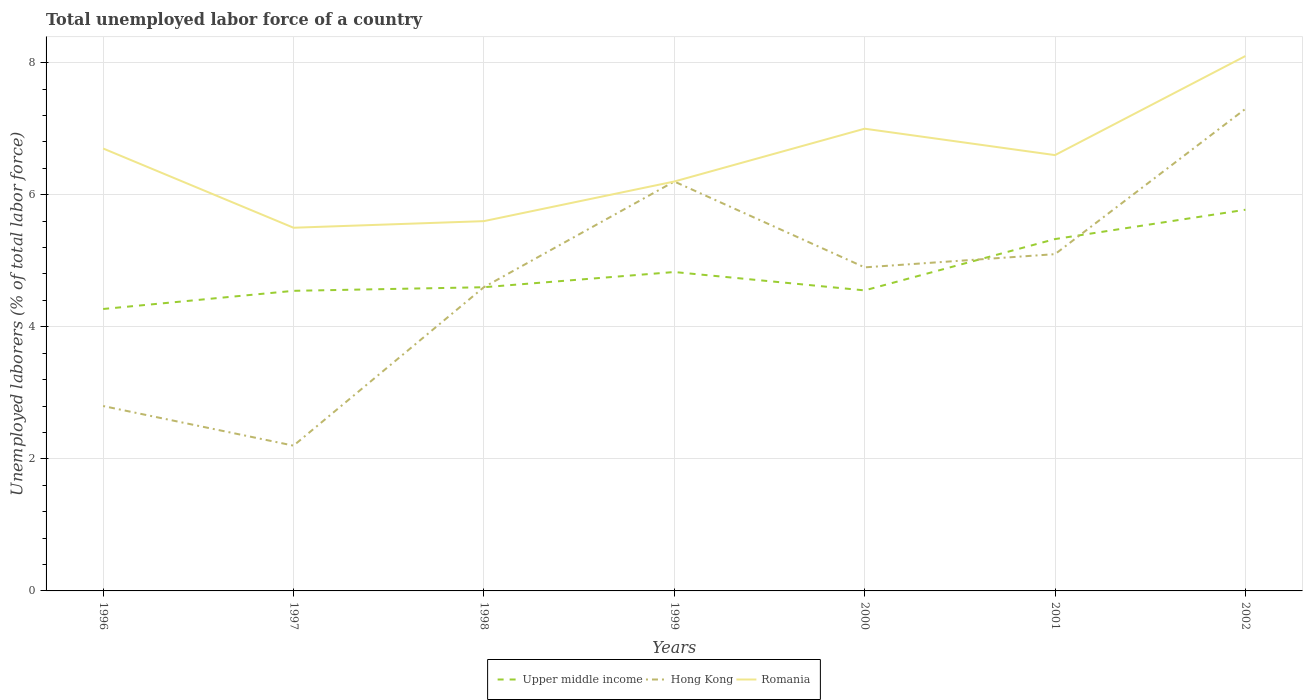How many different coloured lines are there?
Your answer should be very brief. 3. Does the line corresponding to Romania intersect with the line corresponding to Upper middle income?
Offer a very short reply. No. Across all years, what is the maximum total unemployed labor force in Hong Kong?
Provide a succinct answer. 2.2. What is the total total unemployed labor force in Hong Kong in the graph?
Make the answer very short. -1.8. What is the difference between the highest and the second highest total unemployed labor force in Upper middle income?
Keep it short and to the point. 1.5. What is the difference between the highest and the lowest total unemployed labor force in Hong Kong?
Offer a terse response. 4. Is the total unemployed labor force in Upper middle income strictly greater than the total unemployed labor force in Hong Kong over the years?
Make the answer very short. No. How many lines are there?
Offer a very short reply. 3. How many years are there in the graph?
Provide a short and direct response. 7. Are the values on the major ticks of Y-axis written in scientific E-notation?
Provide a short and direct response. No. Does the graph contain any zero values?
Your response must be concise. No. Where does the legend appear in the graph?
Ensure brevity in your answer.  Bottom center. How many legend labels are there?
Your answer should be compact. 3. What is the title of the graph?
Your answer should be very brief. Total unemployed labor force of a country. What is the label or title of the X-axis?
Offer a terse response. Years. What is the label or title of the Y-axis?
Your response must be concise. Unemployed laborers (% of total labor force). What is the Unemployed laborers (% of total labor force) in Upper middle income in 1996?
Your response must be concise. 4.27. What is the Unemployed laborers (% of total labor force) of Hong Kong in 1996?
Offer a terse response. 2.8. What is the Unemployed laborers (% of total labor force) of Romania in 1996?
Offer a very short reply. 6.7. What is the Unemployed laborers (% of total labor force) in Upper middle income in 1997?
Ensure brevity in your answer.  4.54. What is the Unemployed laborers (% of total labor force) of Hong Kong in 1997?
Give a very brief answer. 2.2. What is the Unemployed laborers (% of total labor force) in Romania in 1997?
Make the answer very short. 5.5. What is the Unemployed laborers (% of total labor force) of Upper middle income in 1998?
Ensure brevity in your answer.  4.6. What is the Unemployed laborers (% of total labor force) of Hong Kong in 1998?
Your answer should be very brief. 4.6. What is the Unemployed laborers (% of total labor force) in Romania in 1998?
Offer a terse response. 5.6. What is the Unemployed laborers (% of total labor force) of Upper middle income in 1999?
Your response must be concise. 4.83. What is the Unemployed laborers (% of total labor force) of Hong Kong in 1999?
Offer a terse response. 6.2. What is the Unemployed laborers (% of total labor force) in Romania in 1999?
Your response must be concise. 6.2. What is the Unemployed laborers (% of total labor force) in Upper middle income in 2000?
Your answer should be very brief. 4.55. What is the Unemployed laborers (% of total labor force) in Hong Kong in 2000?
Give a very brief answer. 4.9. What is the Unemployed laborers (% of total labor force) of Upper middle income in 2001?
Your answer should be very brief. 5.33. What is the Unemployed laborers (% of total labor force) in Hong Kong in 2001?
Provide a short and direct response. 5.1. What is the Unemployed laborers (% of total labor force) in Romania in 2001?
Provide a short and direct response. 6.6. What is the Unemployed laborers (% of total labor force) of Upper middle income in 2002?
Ensure brevity in your answer.  5.77. What is the Unemployed laborers (% of total labor force) of Hong Kong in 2002?
Your answer should be compact. 7.3. What is the Unemployed laborers (% of total labor force) of Romania in 2002?
Your answer should be very brief. 8.1. Across all years, what is the maximum Unemployed laborers (% of total labor force) of Upper middle income?
Make the answer very short. 5.77. Across all years, what is the maximum Unemployed laborers (% of total labor force) in Hong Kong?
Your response must be concise. 7.3. Across all years, what is the maximum Unemployed laborers (% of total labor force) of Romania?
Your answer should be very brief. 8.1. Across all years, what is the minimum Unemployed laborers (% of total labor force) in Upper middle income?
Make the answer very short. 4.27. Across all years, what is the minimum Unemployed laborers (% of total labor force) of Hong Kong?
Offer a very short reply. 2.2. Across all years, what is the minimum Unemployed laborers (% of total labor force) in Romania?
Make the answer very short. 5.5. What is the total Unemployed laborers (% of total labor force) in Upper middle income in the graph?
Provide a short and direct response. 33.9. What is the total Unemployed laborers (% of total labor force) in Hong Kong in the graph?
Your response must be concise. 33.1. What is the total Unemployed laborers (% of total labor force) in Romania in the graph?
Your response must be concise. 45.7. What is the difference between the Unemployed laborers (% of total labor force) in Upper middle income in 1996 and that in 1997?
Give a very brief answer. -0.28. What is the difference between the Unemployed laborers (% of total labor force) of Hong Kong in 1996 and that in 1997?
Keep it short and to the point. 0.6. What is the difference between the Unemployed laborers (% of total labor force) of Romania in 1996 and that in 1997?
Make the answer very short. 1.2. What is the difference between the Unemployed laborers (% of total labor force) in Upper middle income in 1996 and that in 1998?
Offer a terse response. -0.33. What is the difference between the Unemployed laborers (% of total labor force) in Upper middle income in 1996 and that in 1999?
Keep it short and to the point. -0.56. What is the difference between the Unemployed laborers (% of total labor force) of Romania in 1996 and that in 1999?
Make the answer very short. 0.5. What is the difference between the Unemployed laborers (% of total labor force) in Upper middle income in 1996 and that in 2000?
Your answer should be compact. -0.28. What is the difference between the Unemployed laborers (% of total labor force) in Romania in 1996 and that in 2000?
Your response must be concise. -0.3. What is the difference between the Unemployed laborers (% of total labor force) in Upper middle income in 1996 and that in 2001?
Make the answer very short. -1.06. What is the difference between the Unemployed laborers (% of total labor force) in Upper middle income in 1996 and that in 2002?
Ensure brevity in your answer.  -1.5. What is the difference between the Unemployed laborers (% of total labor force) in Hong Kong in 1996 and that in 2002?
Ensure brevity in your answer.  -4.5. What is the difference between the Unemployed laborers (% of total labor force) of Upper middle income in 1997 and that in 1998?
Offer a terse response. -0.05. What is the difference between the Unemployed laborers (% of total labor force) in Hong Kong in 1997 and that in 1998?
Ensure brevity in your answer.  -2.4. What is the difference between the Unemployed laborers (% of total labor force) in Upper middle income in 1997 and that in 1999?
Your response must be concise. -0.28. What is the difference between the Unemployed laborers (% of total labor force) of Romania in 1997 and that in 1999?
Ensure brevity in your answer.  -0.7. What is the difference between the Unemployed laborers (% of total labor force) in Upper middle income in 1997 and that in 2000?
Provide a succinct answer. -0.01. What is the difference between the Unemployed laborers (% of total labor force) in Hong Kong in 1997 and that in 2000?
Your answer should be compact. -2.7. What is the difference between the Unemployed laborers (% of total labor force) of Romania in 1997 and that in 2000?
Your answer should be compact. -1.5. What is the difference between the Unemployed laborers (% of total labor force) of Upper middle income in 1997 and that in 2001?
Offer a terse response. -0.78. What is the difference between the Unemployed laborers (% of total labor force) of Hong Kong in 1997 and that in 2001?
Offer a very short reply. -2.9. What is the difference between the Unemployed laborers (% of total labor force) in Romania in 1997 and that in 2001?
Give a very brief answer. -1.1. What is the difference between the Unemployed laborers (% of total labor force) of Upper middle income in 1997 and that in 2002?
Your answer should be very brief. -1.23. What is the difference between the Unemployed laborers (% of total labor force) in Hong Kong in 1997 and that in 2002?
Your answer should be compact. -5.1. What is the difference between the Unemployed laborers (% of total labor force) of Upper middle income in 1998 and that in 1999?
Give a very brief answer. -0.23. What is the difference between the Unemployed laborers (% of total labor force) in Upper middle income in 1998 and that in 2000?
Your response must be concise. 0.05. What is the difference between the Unemployed laborers (% of total labor force) in Hong Kong in 1998 and that in 2000?
Offer a very short reply. -0.3. What is the difference between the Unemployed laborers (% of total labor force) in Romania in 1998 and that in 2000?
Offer a terse response. -1.4. What is the difference between the Unemployed laborers (% of total labor force) of Upper middle income in 1998 and that in 2001?
Offer a terse response. -0.73. What is the difference between the Unemployed laborers (% of total labor force) in Upper middle income in 1998 and that in 2002?
Ensure brevity in your answer.  -1.17. What is the difference between the Unemployed laborers (% of total labor force) in Romania in 1998 and that in 2002?
Offer a terse response. -2.5. What is the difference between the Unemployed laborers (% of total labor force) in Upper middle income in 1999 and that in 2000?
Provide a short and direct response. 0.28. What is the difference between the Unemployed laborers (% of total labor force) in Hong Kong in 1999 and that in 2000?
Provide a short and direct response. 1.3. What is the difference between the Unemployed laborers (% of total labor force) of Upper middle income in 1999 and that in 2001?
Your answer should be very brief. -0.5. What is the difference between the Unemployed laborers (% of total labor force) in Hong Kong in 1999 and that in 2001?
Make the answer very short. 1.1. What is the difference between the Unemployed laborers (% of total labor force) of Romania in 1999 and that in 2001?
Offer a very short reply. -0.4. What is the difference between the Unemployed laborers (% of total labor force) of Upper middle income in 1999 and that in 2002?
Ensure brevity in your answer.  -0.94. What is the difference between the Unemployed laborers (% of total labor force) of Upper middle income in 2000 and that in 2001?
Offer a very short reply. -0.78. What is the difference between the Unemployed laborers (% of total labor force) in Upper middle income in 2000 and that in 2002?
Make the answer very short. -1.22. What is the difference between the Unemployed laborers (% of total labor force) in Romania in 2000 and that in 2002?
Your answer should be compact. -1.1. What is the difference between the Unemployed laborers (% of total labor force) of Upper middle income in 2001 and that in 2002?
Your answer should be compact. -0.44. What is the difference between the Unemployed laborers (% of total labor force) of Hong Kong in 2001 and that in 2002?
Offer a terse response. -2.2. What is the difference between the Unemployed laborers (% of total labor force) in Upper middle income in 1996 and the Unemployed laborers (% of total labor force) in Hong Kong in 1997?
Keep it short and to the point. 2.07. What is the difference between the Unemployed laborers (% of total labor force) in Upper middle income in 1996 and the Unemployed laborers (% of total labor force) in Romania in 1997?
Ensure brevity in your answer.  -1.23. What is the difference between the Unemployed laborers (% of total labor force) of Hong Kong in 1996 and the Unemployed laborers (% of total labor force) of Romania in 1997?
Provide a succinct answer. -2.7. What is the difference between the Unemployed laborers (% of total labor force) of Upper middle income in 1996 and the Unemployed laborers (% of total labor force) of Hong Kong in 1998?
Your response must be concise. -0.33. What is the difference between the Unemployed laborers (% of total labor force) of Upper middle income in 1996 and the Unemployed laborers (% of total labor force) of Romania in 1998?
Make the answer very short. -1.33. What is the difference between the Unemployed laborers (% of total labor force) in Upper middle income in 1996 and the Unemployed laborers (% of total labor force) in Hong Kong in 1999?
Provide a short and direct response. -1.93. What is the difference between the Unemployed laborers (% of total labor force) of Upper middle income in 1996 and the Unemployed laborers (% of total labor force) of Romania in 1999?
Provide a succinct answer. -1.93. What is the difference between the Unemployed laborers (% of total labor force) of Upper middle income in 1996 and the Unemployed laborers (% of total labor force) of Hong Kong in 2000?
Your answer should be very brief. -0.63. What is the difference between the Unemployed laborers (% of total labor force) of Upper middle income in 1996 and the Unemployed laborers (% of total labor force) of Romania in 2000?
Offer a terse response. -2.73. What is the difference between the Unemployed laborers (% of total labor force) in Upper middle income in 1996 and the Unemployed laborers (% of total labor force) in Hong Kong in 2001?
Your answer should be very brief. -0.83. What is the difference between the Unemployed laborers (% of total labor force) in Upper middle income in 1996 and the Unemployed laborers (% of total labor force) in Romania in 2001?
Ensure brevity in your answer.  -2.33. What is the difference between the Unemployed laborers (% of total labor force) of Hong Kong in 1996 and the Unemployed laborers (% of total labor force) of Romania in 2001?
Your answer should be compact. -3.8. What is the difference between the Unemployed laborers (% of total labor force) in Upper middle income in 1996 and the Unemployed laborers (% of total labor force) in Hong Kong in 2002?
Your answer should be very brief. -3.03. What is the difference between the Unemployed laborers (% of total labor force) in Upper middle income in 1996 and the Unemployed laborers (% of total labor force) in Romania in 2002?
Your response must be concise. -3.83. What is the difference between the Unemployed laborers (% of total labor force) in Hong Kong in 1996 and the Unemployed laborers (% of total labor force) in Romania in 2002?
Your answer should be compact. -5.3. What is the difference between the Unemployed laborers (% of total labor force) of Upper middle income in 1997 and the Unemployed laborers (% of total labor force) of Hong Kong in 1998?
Ensure brevity in your answer.  -0.06. What is the difference between the Unemployed laborers (% of total labor force) of Upper middle income in 1997 and the Unemployed laborers (% of total labor force) of Romania in 1998?
Keep it short and to the point. -1.06. What is the difference between the Unemployed laborers (% of total labor force) of Hong Kong in 1997 and the Unemployed laborers (% of total labor force) of Romania in 1998?
Give a very brief answer. -3.4. What is the difference between the Unemployed laborers (% of total labor force) of Upper middle income in 1997 and the Unemployed laborers (% of total labor force) of Hong Kong in 1999?
Your response must be concise. -1.66. What is the difference between the Unemployed laborers (% of total labor force) of Upper middle income in 1997 and the Unemployed laborers (% of total labor force) of Romania in 1999?
Keep it short and to the point. -1.66. What is the difference between the Unemployed laborers (% of total labor force) in Upper middle income in 1997 and the Unemployed laborers (% of total labor force) in Hong Kong in 2000?
Offer a terse response. -0.36. What is the difference between the Unemployed laborers (% of total labor force) in Upper middle income in 1997 and the Unemployed laborers (% of total labor force) in Romania in 2000?
Offer a very short reply. -2.46. What is the difference between the Unemployed laborers (% of total labor force) of Hong Kong in 1997 and the Unemployed laborers (% of total labor force) of Romania in 2000?
Give a very brief answer. -4.8. What is the difference between the Unemployed laborers (% of total labor force) of Upper middle income in 1997 and the Unemployed laborers (% of total labor force) of Hong Kong in 2001?
Ensure brevity in your answer.  -0.56. What is the difference between the Unemployed laborers (% of total labor force) of Upper middle income in 1997 and the Unemployed laborers (% of total labor force) of Romania in 2001?
Your answer should be very brief. -2.06. What is the difference between the Unemployed laborers (% of total labor force) of Hong Kong in 1997 and the Unemployed laborers (% of total labor force) of Romania in 2001?
Ensure brevity in your answer.  -4.4. What is the difference between the Unemployed laborers (% of total labor force) in Upper middle income in 1997 and the Unemployed laborers (% of total labor force) in Hong Kong in 2002?
Keep it short and to the point. -2.76. What is the difference between the Unemployed laborers (% of total labor force) of Upper middle income in 1997 and the Unemployed laborers (% of total labor force) of Romania in 2002?
Your response must be concise. -3.56. What is the difference between the Unemployed laborers (% of total labor force) of Hong Kong in 1997 and the Unemployed laborers (% of total labor force) of Romania in 2002?
Make the answer very short. -5.9. What is the difference between the Unemployed laborers (% of total labor force) in Upper middle income in 1998 and the Unemployed laborers (% of total labor force) in Hong Kong in 1999?
Offer a terse response. -1.6. What is the difference between the Unemployed laborers (% of total labor force) in Upper middle income in 1998 and the Unemployed laborers (% of total labor force) in Romania in 1999?
Ensure brevity in your answer.  -1.6. What is the difference between the Unemployed laborers (% of total labor force) in Upper middle income in 1998 and the Unemployed laborers (% of total labor force) in Hong Kong in 2000?
Your response must be concise. -0.3. What is the difference between the Unemployed laborers (% of total labor force) in Upper middle income in 1998 and the Unemployed laborers (% of total labor force) in Romania in 2000?
Provide a succinct answer. -2.4. What is the difference between the Unemployed laborers (% of total labor force) of Upper middle income in 1998 and the Unemployed laborers (% of total labor force) of Hong Kong in 2001?
Keep it short and to the point. -0.5. What is the difference between the Unemployed laborers (% of total labor force) of Upper middle income in 1998 and the Unemployed laborers (% of total labor force) of Romania in 2001?
Provide a short and direct response. -2. What is the difference between the Unemployed laborers (% of total labor force) of Hong Kong in 1998 and the Unemployed laborers (% of total labor force) of Romania in 2001?
Offer a very short reply. -2. What is the difference between the Unemployed laborers (% of total labor force) of Upper middle income in 1998 and the Unemployed laborers (% of total labor force) of Hong Kong in 2002?
Your answer should be very brief. -2.7. What is the difference between the Unemployed laborers (% of total labor force) in Upper middle income in 1998 and the Unemployed laborers (% of total labor force) in Romania in 2002?
Provide a succinct answer. -3.5. What is the difference between the Unemployed laborers (% of total labor force) in Hong Kong in 1998 and the Unemployed laborers (% of total labor force) in Romania in 2002?
Keep it short and to the point. -3.5. What is the difference between the Unemployed laborers (% of total labor force) in Upper middle income in 1999 and the Unemployed laborers (% of total labor force) in Hong Kong in 2000?
Keep it short and to the point. -0.07. What is the difference between the Unemployed laborers (% of total labor force) in Upper middle income in 1999 and the Unemployed laborers (% of total labor force) in Romania in 2000?
Give a very brief answer. -2.17. What is the difference between the Unemployed laborers (% of total labor force) in Hong Kong in 1999 and the Unemployed laborers (% of total labor force) in Romania in 2000?
Your answer should be compact. -0.8. What is the difference between the Unemployed laborers (% of total labor force) of Upper middle income in 1999 and the Unemployed laborers (% of total labor force) of Hong Kong in 2001?
Make the answer very short. -0.27. What is the difference between the Unemployed laborers (% of total labor force) in Upper middle income in 1999 and the Unemployed laborers (% of total labor force) in Romania in 2001?
Provide a short and direct response. -1.77. What is the difference between the Unemployed laborers (% of total labor force) in Hong Kong in 1999 and the Unemployed laborers (% of total labor force) in Romania in 2001?
Provide a short and direct response. -0.4. What is the difference between the Unemployed laborers (% of total labor force) of Upper middle income in 1999 and the Unemployed laborers (% of total labor force) of Hong Kong in 2002?
Give a very brief answer. -2.47. What is the difference between the Unemployed laborers (% of total labor force) of Upper middle income in 1999 and the Unemployed laborers (% of total labor force) of Romania in 2002?
Provide a short and direct response. -3.27. What is the difference between the Unemployed laborers (% of total labor force) in Hong Kong in 1999 and the Unemployed laborers (% of total labor force) in Romania in 2002?
Offer a terse response. -1.9. What is the difference between the Unemployed laborers (% of total labor force) in Upper middle income in 2000 and the Unemployed laborers (% of total labor force) in Hong Kong in 2001?
Ensure brevity in your answer.  -0.55. What is the difference between the Unemployed laborers (% of total labor force) of Upper middle income in 2000 and the Unemployed laborers (% of total labor force) of Romania in 2001?
Offer a terse response. -2.05. What is the difference between the Unemployed laborers (% of total labor force) in Hong Kong in 2000 and the Unemployed laborers (% of total labor force) in Romania in 2001?
Your answer should be very brief. -1.7. What is the difference between the Unemployed laborers (% of total labor force) in Upper middle income in 2000 and the Unemployed laborers (% of total labor force) in Hong Kong in 2002?
Keep it short and to the point. -2.75. What is the difference between the Unemployed laborers (% of total labor force) of Upper middle income in 2000 and the Unemployed laborers (% of total labor force) of Romania in 2002?
Ensure brevity in your answer.  -3.55. What is the difference between the Unemployed laborers (% of total labor force) in Upper middle income in 2001 and the Unemployed laborers (% of total labor force) in Hong Kong in 2002?
Provide a short and direct response. -1.97. What is the difference between the Unemployed laborers (% of total labor force) of Upper middle income in 2001 and the Unemployed laborers (% of total labor force) of Romania in 2002?
Provide a succinct answer. -2.77. What is the average Unemployed laborers (% of total labor force) of Upper middle income per year?
Offer a very short reply. 4.84. What is the average Unemployed laborers (% of total labor force) of Hong Kong per year?
Your answer should be very brief. 4.73. What is the average Unemployed laborers (% of total labor force) of Romania per year?
Ensure brevity in your answer.  6.53. In the year 1996, what is the difference between the Unemployed laborers (% of total labor force) in Upper middle income and Unemployed laborers (% of total labor force) in Hong Kong?
Give a very brief answer. 1.47. In the year 1996, what is the difference between the Unemployed laborers (% of total labor force) of Upper middle income and Unemployed laborers (% of total labor force) of Romania?
Your answer should be compact. -2.43. In the year 1996, what is the difference between the Unemployed laborers (% of total labor force) of Hong Kong and Unemployed laborers (% of total labor force) of Romania?
Your answer should be very brief. -3.9. In the year 1997, what is the difference between the Unemployed laborers (% of total labor force) of Upper middle income and Unemployed laborers (% of total labor force) of Hong Kong?
Provide a short and direct response. 2.34. In the year 1997, what is the difference between the Unemployed laborers (% of total labor force) of Upper middle income and Unemployed laborers (% of total labor force) of Romania?
Keep it short and to the point. -0.96. In the year 1997, what is the difference between the Unemployed laborers (% of total labor force) of Hong Kong and Unemployed laborers (% of total labor force) of Romania?
Provide a succinct answer. -3.3. In the year 1998, what is the difference between the Unemployed laborers (% of total labor force) in Upper middle income and Unemployed laborers (% of total labor force) in Hong Kong?
Offer a very short reply. -0. In the year 1998, what is the difference between the Unemployed laborers (% of total labor force) of Upper middle income and Unemployed laborers (% of total labor force) of Romania?
Offer a very short reply. -1. In the year 1999, what is the difference between the Unemployed laborers (% of total labor force) of Upper middle income and Unemployed laborers (% of total labor force) of Hong Kong?
Your response must be concise. -1.37. In the year 1999, what is the difference between the Unemployed laborers (% of total labor force) of Upper middle income and Unemployed laborers (% of total labor force) of Romania?
Your answer should be compact. -1.37. In the year 1999, what is the difference between the Unemployed laborers (% of total labor force) in Hong Kong and Unemployed laborers (% of total labor force) in Romania?
Ensure brevity in your answer.  0. In the year 2000, what is the difference between the Unemployed laborers (% of total labor force) in Upper middle income and Unemployed laborers (% of total labor force) in Hong Kong?
Your response must be concise. -0.35. In the year 2000, what is the difference between the Unemployed laborers (% of total labor force) of Upper middle income and Unemployed laborers (% of total labor force) of Romania?
Your response must be concise. -2.45. In the year 2000, what is the difference between the Unemployed laborers (% of total labor force) of Hong Kong and Unemployed laborers (% of total labor force) of Romania?
Provide a succinct answer. -2.1. In the year 2001, what is the difference between the Unemployed laborers (% of total labor force) in Upper middle income and Unemployed laborers (% of total labor force) in Hong Kong?
Keep it short and to the point. 0.23. In the year 2001, what is the difference between the Unemployed laborers (% of total labor force) of Upper middle income and Unemployed laborers (% of total labor force) of Romania?
Offer a terse response. -1.27. In the year 2001, what is the difference between the Unemployed laborers (% of total labor force) of Hong Kong and Unemployed laborers (% of total labor force) of Romania?
Keep it short and to the point. -1.5. In the year 2002, what is the difference between the Unemployed laborers (% of total labor force) of Upper middle income and Unemployed laborers (% of total labor force) of Hong Kong?
Provide a short and direct response. -1.53. In the year 2002, what is the difference between the Unemployed laborers (% of total labor force) of Upper middle income and Unemployed laborers (% of total labor force) of Romania?
Give a very brief answer. -2.33. What is the ratio of the Unemployed laborers (% of total labor force) of Upper middle income in 1996 to that in 1997?
Give a very brief answer. 0.94. What is the ratio of the Unemployed laborers (% of total labor force) of Hong Kong in 1996 to that in 1997?
Your response must be concise. 1.27. What is the ratio of the Unemployed laborers (% of total labor force) in Romania in 1996 to that in 1997?
Give a very brief answer. 1.22. What is the ratio of the Unemployed laborers (% of total labor force) of Upper middle income in 1996 to that in 1998?
Give a very brief answer. 0.93. What is the ratio of the Unemployed laborers (% of total labor force) of Hong Kong in 1996 to that in 1998?
Provide a short and direct response. 0.61. What is the ratio of the Unemployed laborers (% of total labor force) in Romania in 1996 to that in 1998?
Your response must be concise. 1.2. What is the ratio of the Unemployed laborers (% of total labor force) of Upper middle income in 1996 to that in 1999?
Your answer should be compact. 0.88. What is the ratio of the Unemployed laborers (% of total labor force) in Hong Kong in 1996 to that in 1999?
Offer a very short reply. 0.45. What is the ratio of the Unemployed laborers (% of total labor force) of Romania in 1996 to that in 1999?
Provide a succinct answer. 1.08. What is the ratio of the Unemployed laborers (% of total labor force) in Upper middle income in 1996 to that in 2000?
Keep it short and to the point. 0.94. What is the ratio of the Unemployed laborers (% of total labor force) in Romania in 1996 to that in 2000?
Keep it short and to the point. 0.96. What is the ratio of the Unemployed laborers (% of total labor force) in Upper middle income in 1996 to that in 2001?
Your answer should be compact. 0.8. What is the ratio of the Unemployed laborers (% of total labor force) in Hong Kong in 1996 to that in 2001?
Your answer should be compact. 0.55. What is the ratio of the Unemployed laborers (% of total labor force) of Romania in 1996 to that in 2001?
Your answer should be compact. 1.02. What is the ratio of the Unemployed laborers (% of total labor force) of Upper middle income in 1996 to that in 2002?
Your answer should be very brief. 0.74. What is the ratio of the Unemployed laborers (% of total labor force) of Hong Kong in 1996 to that in 2002?
Offer a very short reply. 0.38. What is the ratio of the Unemployed laborers (% of total labor force) of Romania in 1996 to that in 2002?
Your answer should be very brief. 0.83. What is the ratio of the Unemployed laborers (% of total labor force) in Upper middle income in 1997 to that in 1998?
Offer a very short reply. 0.99. What is the ratio of the Unemployed laborers (% of total labor force) in Hong Kong in 1997 to that in 1998?
Offer a terse response. 0.48. What is the ratio of the Unemployed laborers (% of total labor force) in Romania in 1997 to that in 1998?
Your answer should be very brief. 0.98. What is the ratio of the Unemployed laborers (% of total labor force) of Upper middle income in 1997 to that in 1999?
Keep it short and to the point. 0.94. What is the ratio of the Unemployed laborers (% of total labor force) of Hong Kong in 1997 to that in 1999?
Your answer should be very brief. 0.35. What is the ratio of the Unemployed laborers (% of total labor force) of Romania in 1997 to that in 1999?
Give a very brief answer. 0.89. What is the ratio of the Unemployed laborers (% of total labor force) of Upper middle income in 1997 to that in 2000?
Your answer should be compact. 1. What is the ratio of the Unemployed laborers (% of total labor force) of Hong Kong in 1997 to that in 2000?
Provide a succinct answer. 0.45. What is the ratio of the Unemployed laborers (% of total labor force) in Romania in 1997 to that in 2000?
Provide a succinct answer. 0.79. What is the ratio of the Unemployed laborers (% of total labor force) of Upper middle income in 1997 to that in 2001?
Your response must be concise. 0.85. What is the ratio of the Unemployed laborers (% of total labor force) in Hong Kong in 1997 to that in 2001?
Keep it short and to the point. 0.43. What is the ratio of the Unemployed laborers (% of total labor force) of Upper middle income in 1997 to that in 2002?
Provide a short and direct response. 0.79. What is the ratio of the Unemployed laborers (% of total labor force) of Hong Kong in 1997 to that in 2002?
Provide a short and direct response. 0.3. What is the ratio of the Unemployed laborers (% of total labor force) of Romania in 1997 to that in 2002?
Your answer should be very brief. 0.68. What is the ratio of the Unemployed laborers (% of total labor force) in Upper middle income in 1998 to that in 1999?
Offer a very short reply. 0.95. What is the ratio of the Unemployed laborers (% of total labor force) in Hong Kong in 1998 to that in 1999?
Provide a succinct answer. 0.74. What is the ratio of the Unemployed laborers (% of total labor force) in Romania in 1998 to that in 1999?
Keep it short and to the point. 0.9. What is the ratio of the Unemployed laborers (% of total labor force) of Upper middle income in 1998 to that in 2000?
Provide a succinct answer. 1.01. What is the ratio of the Unemployed laborers (% of total labor force) of Hong Kong in 1998 to that in 2000?
Ensure brevity in your answer.  0.94. What is the ratio of the Unemployed laborers (% of total labor force) in Upper middle income in 1998 to that in 2001?
Your response must be concise. 0.86. What is the ratio of the Unemployed laborers (% of total labor force) in Hong Kong in 1998 to that in 2001?
Provide a succinct answer. 0.9. What is the ratio of the Unemployed laborers (% of total labor force) in Romania in 1998 to that in 2001?
Your answer should be compact. 0.85. What is the ratio of the Unemployed laborers (% of total labor force) of Upper middle income in 1998 to that in 2002?
Offer a terse response. 0.8. What is the ratio of the Unemployed laborers (% of total labor force) in Hong Kong in 1998 to that in 2002?
Make the answer very short. 0.63. What is the ratio of the Unemployed laborers (% of total labor force) of Romania in 1998 to that in 2002?
Provide a succinct answer. 0.69. What is the ratio of the Unemployed laborers (% of total labor force) in Upper middle income in 1999 to that in 2000?
Give a very brief answer. 1.06. What is the ratio of the Unemployed laborers (% of total labor force) of Hong Kong in 1999 to that in 2000?
Offer a very short reply. 1.27. What is the ratio of the Unemployed laborers (% of total labor force) of Romania in 1999 to that in 2000?
Your answer should be very brief. 0.89. What is the ratio of the Unemployed laborers (% of total labor force) of Upper middle income in 1999 to that in 2001?
Provide a succinct answer. 0.91. What is the ratio of the Unemployed laborers (% of total labor force) of Hong Kong in 1999 to that in 2001?
Ensure brevity in your answer.  1.22. What is the ratio of the Unemployed laborers (% of total labor force) in Romania in 1999 to that in 2001?
Provide a succinct answer. 0.94. What is the ratio of the Unemployed laborers (% of total labor force) in Upper middle income in 1999 to that in 2002?
Your answer should be very brief. 0.84. What is the ratio of the Unemployed laborers (% of total labor force) of Hong Kong in 1999 to that in 2002?
Provide a succinct answer. 0.85. What is the ratio of the Unemployed laborers (% of total labor force) of Romania in 1999 to that in 2002?
Offer a very short reply. 0.77. What is the ratio of the Unemployed laborers (% of total labor force) in Upper middle income in 2000 to that in 2001?
Keep it short and to the point. 0.85. What is the ratio of the Unemployed laborers (% of total labor force) in Hong Kong in 2000 to that in 2001?
Give a very brief answer. 0.96. What is the ratio of the Unemployed laborers (% of total labor force) of Romania in 2000 to that in 2001?
Keep it short and to the point. 1.06. What is the ratio of the Unemployed laborers (% of total labor force) in Upper middle income in 2000 to that in 2002?
Ensure brevity in your answer.  0.79. What is the ratio of the Unemployed laborers (% of total labor force) in Hong Kong in 2000 to that in 2002?
Make the answer very short. 0.67. What is the ratio of the Unemployed laborers (% of total labor force) of Romania in 2000 to that in 2002?
Offer a terse response. 0.86. What is the ratio of the Unemployed laborers (% of total labor force) of Upper middle income in 2001 to that in 2002?
Your answer should be very brief. 0.92. What is the ratio of the Unemployed laborers (% of total labor force) of Hong Kong in 2001 to that in 2002?
Provide a short and direct response. 0.7. What is the ratio of the Unemployed laborers (% of total labor force) in Romania in 2001 to that in 2002?
Ensure brevity in your answer.  0.81. What is the difference between the highest and the second highest Unemployed laborers (% of total labor force) in Upper middle income?
Offer a terse response. 0.44. What is the difference between the highest and the second highest Unemployed laborers (% of total labor force) in Hong Kong?
Offer a terse response. 1.1. What is the difference between the highest and the second highest Unemployed laborers (% of total labor force) in Romania?
Your response must be concise. 1.1. What is the difference between the highest and the lowest Unemployed laborers (% of total labor force) in Upper middle income?
Make the answer very short. 1.5. 